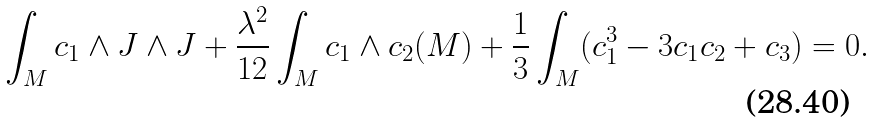<formula> <loc_0><loc_0><loc_500><loc_500>\int _ { M } c _ { 1 } \wedge J \wedge J + \frac { \lambda ^ { 2 } } { 1 2 } \int _ { M } c _ { 1 } \wedge c _ { 2 } ( M ) + \frac { 1 } { 3 } \int _ { M } ( c _ { 1 } ^ { 3 } - 3 c _ { 1 } c _ { 2 } + c _ { 3 } ) = 0 .</formula> 